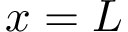<formula> <loc_0><loc_0><loc_500><loc_500>x = L</formula> 